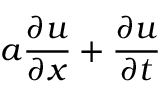Convert formula to latex. <formula><loc_0><loc_0><loc_500><loc_500>a { \frac { \partial u } { \partial x } } + { \frac { \partial u } { \partial t } }</formula> 